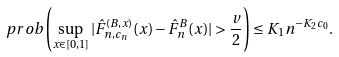<formula> <loc_0><loc_0><loc_500><loc_500>\ p r o b \left ( \sup _ { x \in [ 0 , 1 ] } | \hat { F } _ { n , c _ { n } } ^ { ( B , x ) } ( x ) - \hat { F } _ { n } ^ { B } ( x ) | > \frac { v } { 2 } \right ) \leq K _ { 1 } n ^ { - K _ { 2 } c _ { 0 } } .</formula> 